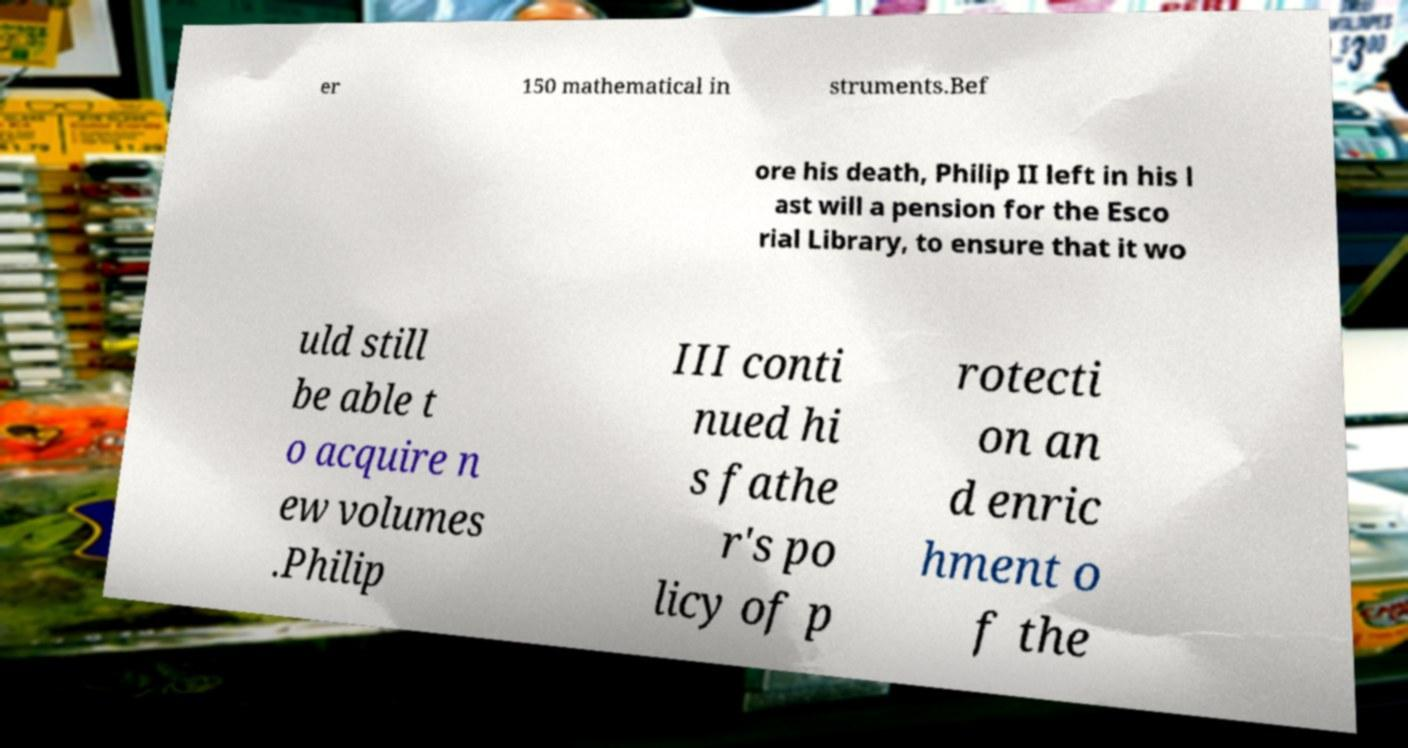There's text embedded in this image that I need extracted. Can you transcribe it verbatim? er 150 mathematical in struments.Bef ore his death, Philip II left in his l ast will a pension for the Esco rial Library, to ensure that it wo uld still be able t o acquire n ew volumes .Philip III conti nued hi s fathe r's po licy of p rotecti on an d enric hment o f the 